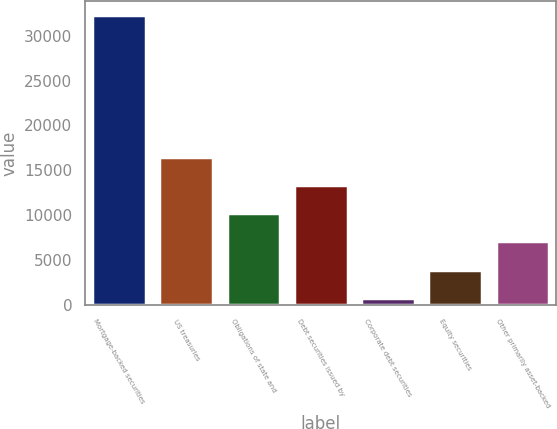Convert chart to OTSL. <chart><loc_0><loc_0><loc_500><loc_500><bar_chart><fcel>Mortgage-backed securities<fcel>US treasuries<fcel>Obligations of state and<fcel>Debt securities issued by<fcel>Corporate debt securities<fcel>Equity securities<fcel>Other primarily asset-backed<nl><fcel>32248<fcel>16533<fcel>10247<fcel>13390<fcel>818<fcel>3961<fcel>7104<nl></chart> 